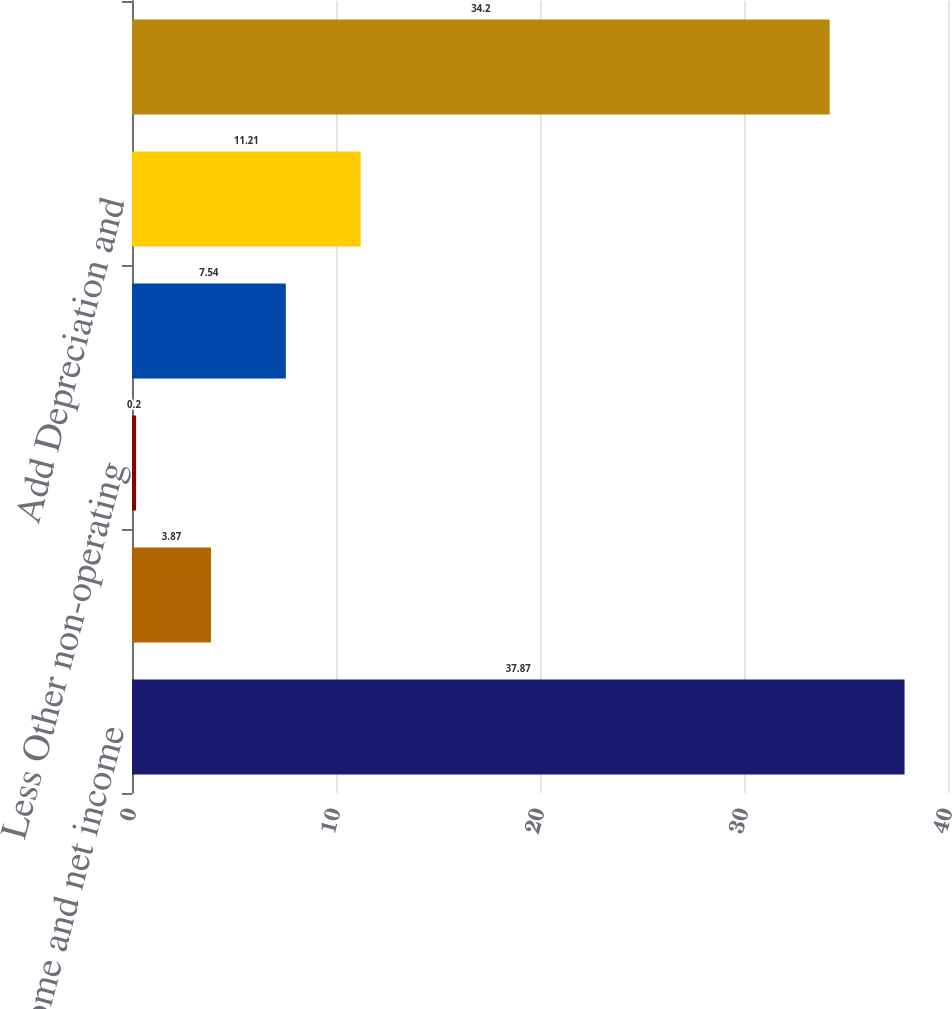Convert chart. <chart><loc_0><loc_0><loc_500><loc_500><bar_chart><fcel>Net income and net income<fcel>Add Interest expense<fcel>Less Other non-operating<fcel>Add Income tax provision<fcel>Add Depreciation and<fcel>Adjusted EBITDA and adjusted<nl><fcel>37.87<fcel>3.87<fcel>0.2<fcel>7.54<fcel>11.21<fcel>34.2<nl></chart> 